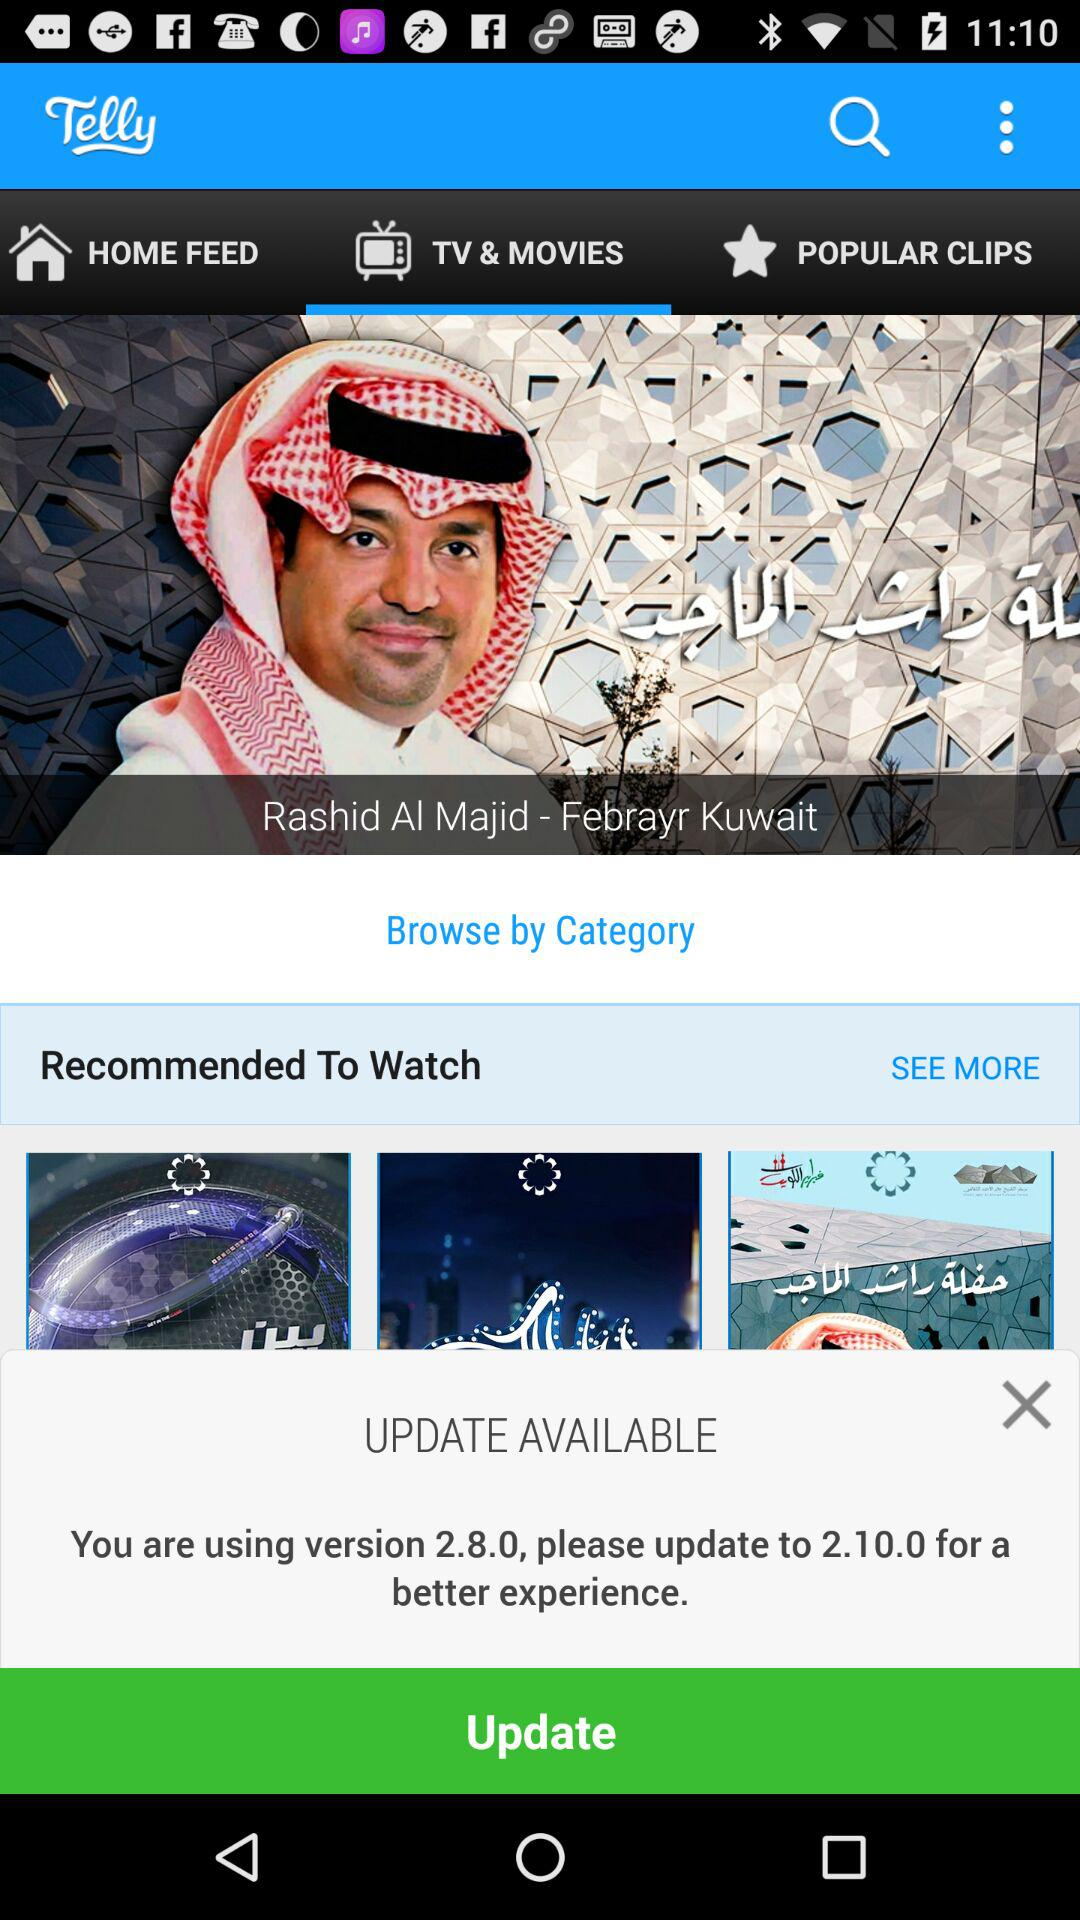What is the current version? The current version is 2.8.0. 